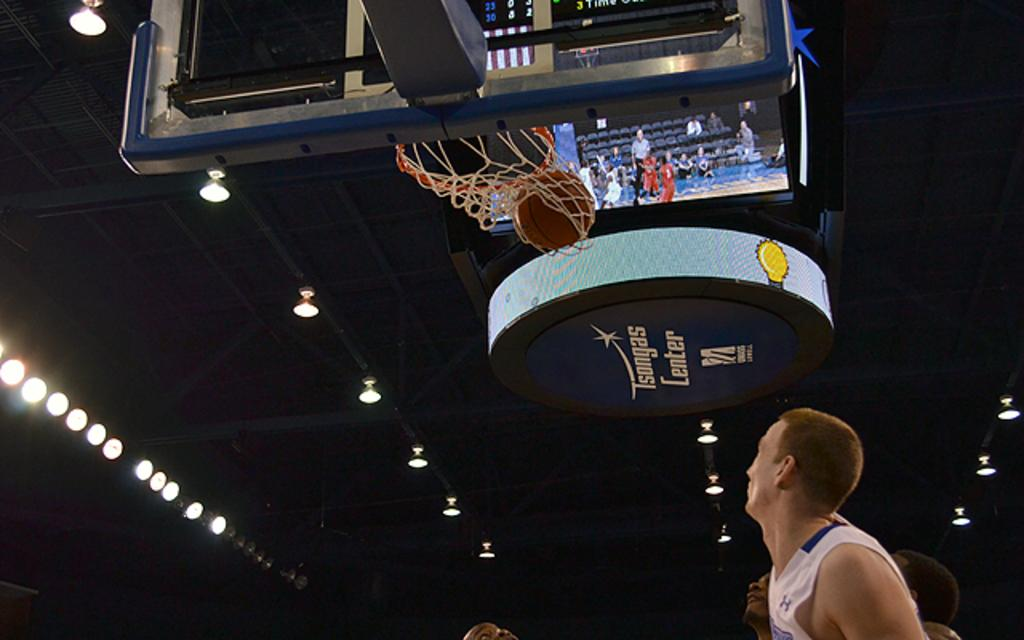Provide a one-sentence caption for the provided image. Basketball players watch a basketball going through the net at Tsongas Center. 